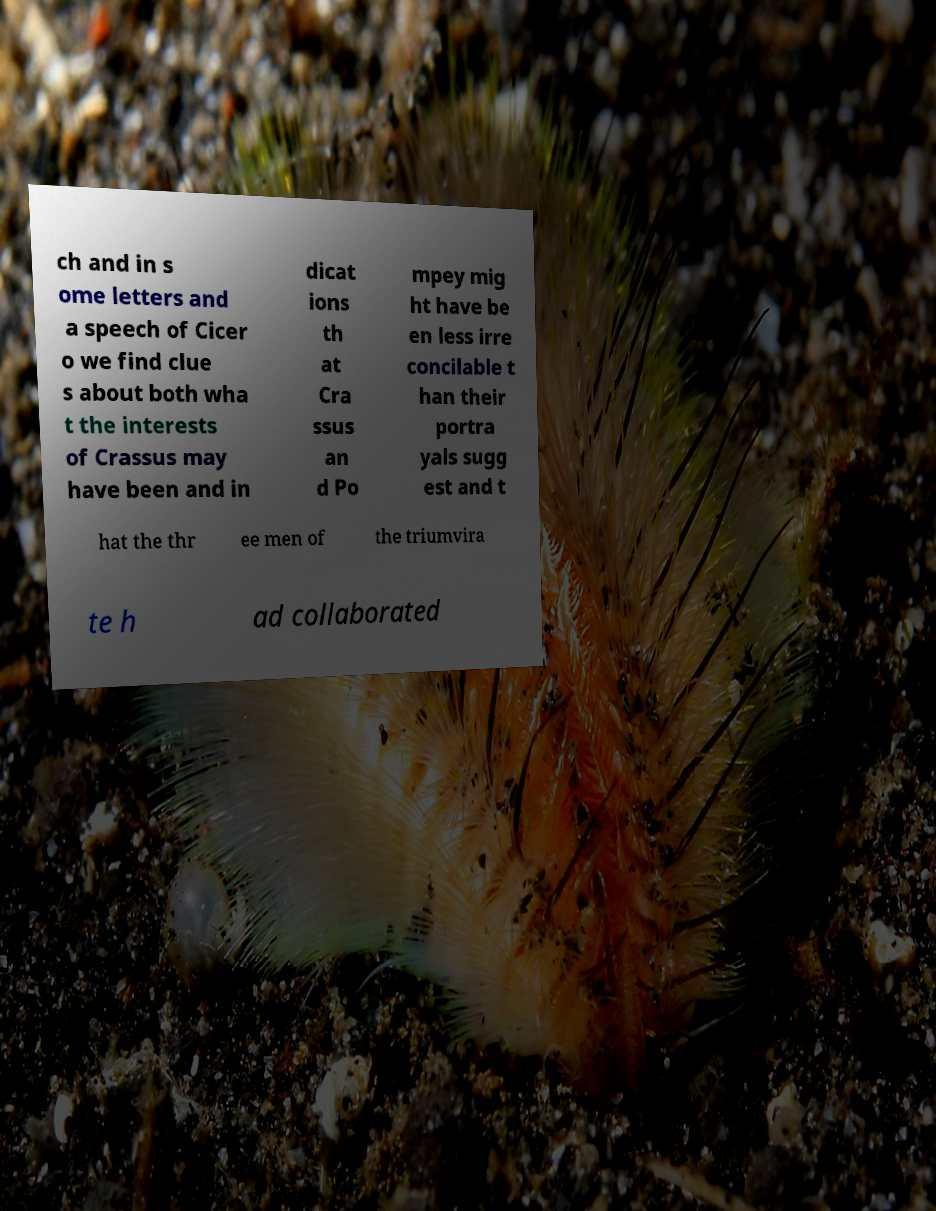Can you read and provide the text displayed in the image?This photo seems to have some interesting text. Can you extract and type it out for me? ch and in s ome letters and a speech of Cicer o we find clue s about both wha t the interests of Crassus may have been and in dicat ions th at Cra ssus an d Po mpey mig ht have be en less irre concilable t han their portra yals sugg est and t hat the thr ee men of the triumvira te h ad collaborated 